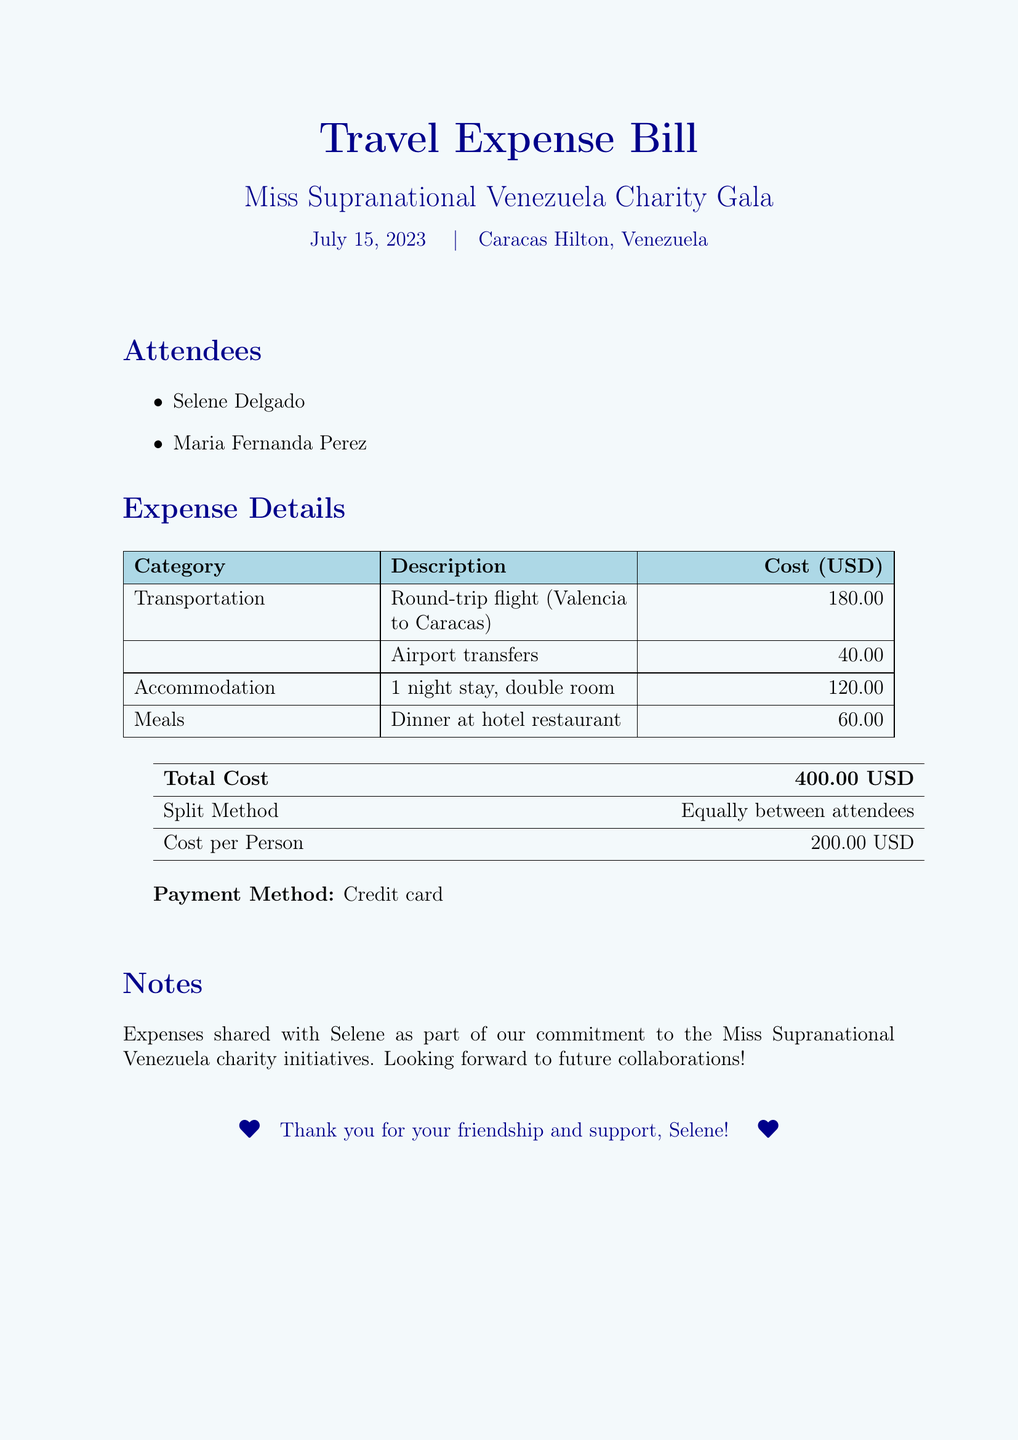What is the title of the event? The title of the event is mentioned prominently at the top of the document.
Answer: Miss Supranational Venezuela Charity Gala Who are the attendees? The attendees' names are listed in the document under the "Attendees" section.
Answer: Selene Delgado, Maria Fernanda Perez What is the total cost of the expenses? The total cost is clearly stated in the last table of the document.
Answer: 400.00 USD How much was spent on transportation? The transportation costs are detailed in the "Expense Details" section of the document.
Answer: 220.00 How will the costs be split? The split method is outlined in the summary table at the end of the document.
Answer: Equally between attendees What was the cost per person? The cost per person is stated in the summary table at the end of the document.
Answer: 200.00 USD When was the charity gala held? The date of the gala is mentioned in the header section of the document.
Answer: July 15, 2023 What payment method was used? The payment method is noted at the end of the expense details.
Answer: Credit card What kind of room was booked for accommodation? The description of the accommodation can be found in the expense breakdown.
Answer: Double room 